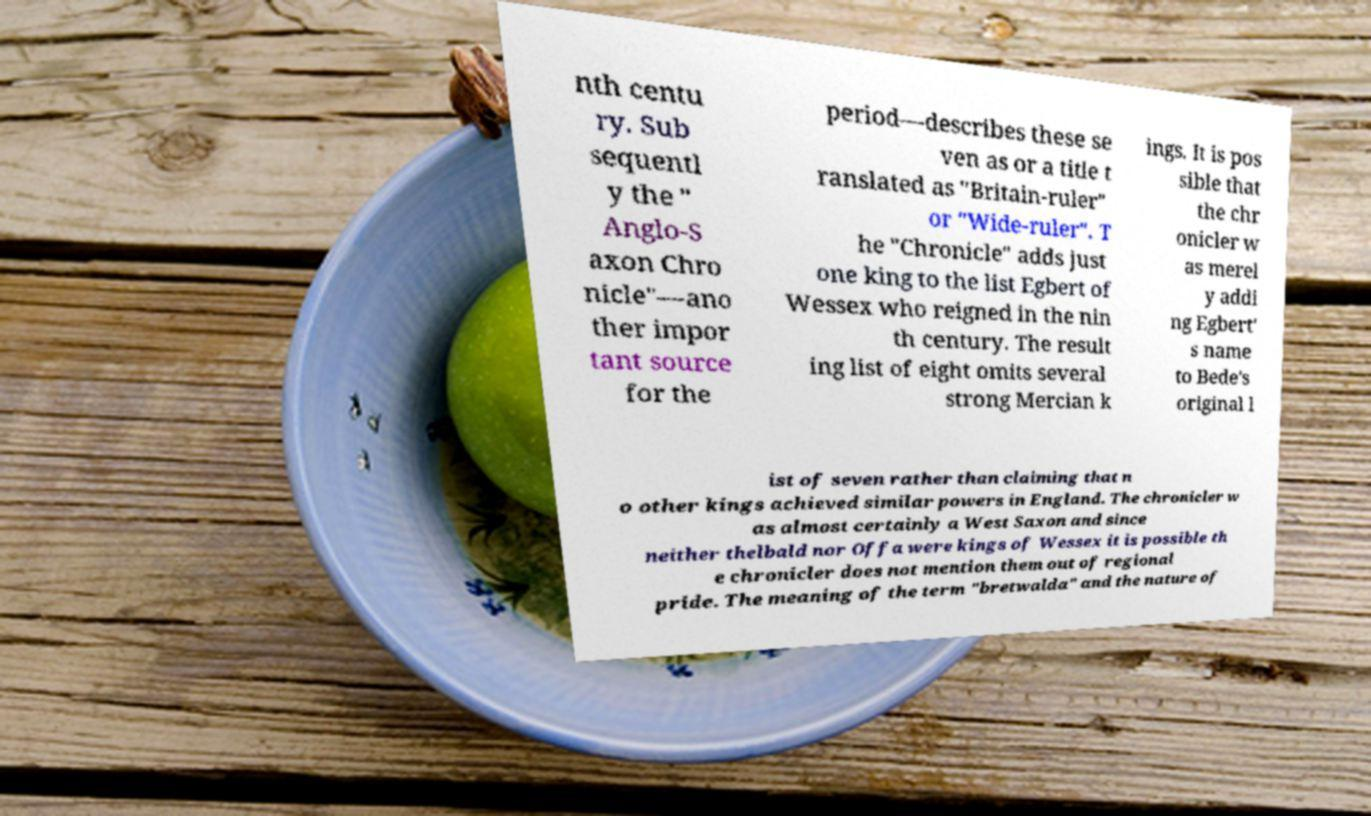Can you accurately transcribe the text from the provided image for me? nth centu ry. Sub sequentl y the " Anglo-S axon Chro nicle"—ano ther impor tant source for the period—describes these se ven as or a title t ranslated as "Britain-ruler" or "Wide-ruler". T he "Chronicle" adds just one king to the list Egbert of Wessex who reigned in the nin th century. The result ing list of eight omits several strong Mercian k ings. It is pos sible that the chr onicler w as merel y addi ng Egbert' s name to Bede's original l ist of seven rather than claiming that n o other kings achieved similar powers in England. The chronicler w as almost certainly a West Saxon and since neither thelbald nor Offa were kings of Wessex it is possible th e chronicler does not mention them out of regional pride. The meaning of the term "bretwalda" and the nature of 